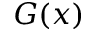Convert formula to latex. <formula><loc_0><loc_0><loc_500><loc_500>G ( x )</formula> 